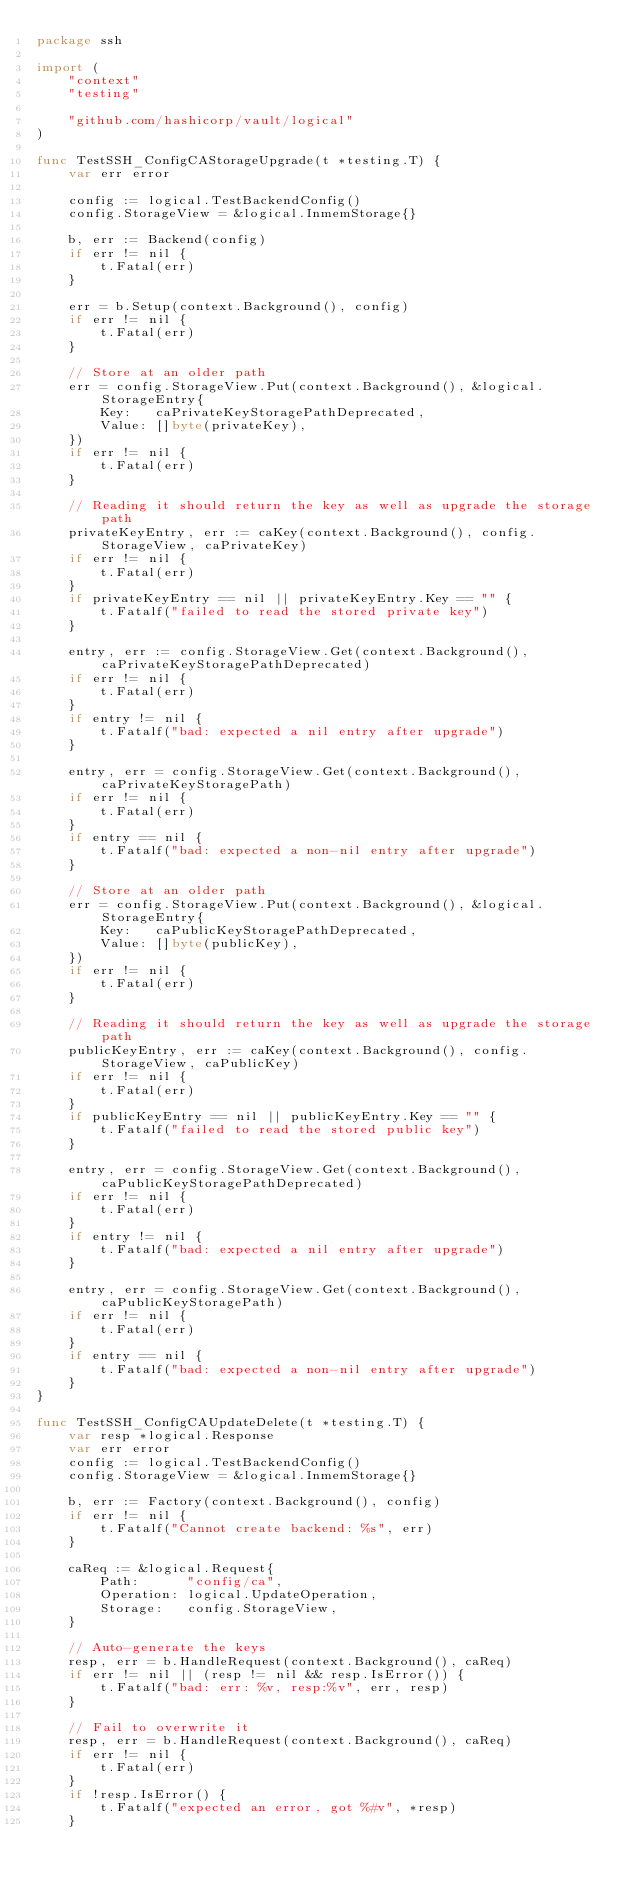Convert code to text. <code><loc_0><loc_0><loc_500><loc_500><_Go_>package ssh

import (
	"context"
	"testing"

	"github.com/hashicorp/vault/logical"
)

func TestSSH_ConfigCAStorageUpgrade(t *testing.T) {
	var err error

	config := logical.TestBackendConfig()
	config.StorageView = &logical.InmemStorage{}

	b, err := Backend(config)
	if err != nil {
		t.Fatal(err)
	}

	err = b.Setup(context.Background(), config)
	if err != nil {
		t.Fatal(err)
	}

	// Store at an older path
	err = config.StorageView.Put(context.Background(), &logical.StorageEntry{
		Key:   caPrivateKeyStoragePathDeprecated,
		Value: []byte(privateKey),
	})
	if err != nil {
		t.Fatal(err)
	}

	// Reading it should return the key as well as upgrade the storage path
	privateKeyEntry, err := caKey(context.Background(), config.StorageView, caPrivateKey)
	if err != nil {
		t.Fatal(err)
	}
	if privateKeyEntry == nil || privateKeyEntry.Key == "" {
		t.Fatalf("failed to read the stored private key")
	}

	entry, err := config.StorageView.Get(context.Background(), caPrivateKeyStoragePathDeprecated)
	if err != nil {
		t.Fatal(err)
	}
	if entry != nil {
		t.Fatalf("bad: expected a nil entry after upgrade")
	}

	entry, err = config.StorageView.Get(context.Background(), caPrivateKeyStoragePath)
	if err != nil {
		t.Fatal(err)
	}
	if entry == nil {
		t.Fatalf("bad: expected a non-nil entry after upgrade")
	}

	// Store at an older path
	err = config.StorageView.Put(context.Background(), &logical.StorageEntry{
		Key:   caPublicKeyStoragePathDeprecated,
		Value: []byte(publicKey),
	})
	if err != nil {
		t.Fatal(err)
	}

	// Reading it should return the key as well as upgrade the storage path
	publicKeyEntry, err := caKey(context.Background(), config.StorageView, caPublicKey)
	if err != nil {
		t.Fatal(err)
	}
	if publicKeyEntry == nil || publicKeyEntry.Key == "" {
		t.Fatalf("failed to read the stored public key")
	}

	entry, err = config.StorageView.Get(context.Background(), caPublicKeyStoragePathDeprecated)
	if err != nil {
		t.Fatal(err)
	}
	if entry != nil {
		t.Fatalf("bad: expected a nil entry after upgrade")
	}

	entry, err = config.StorageView.Get(context.Background(), caPublicKeyStoragePath)
	if err != nil {
		t.Fatal(err)
	}
	if entry == nil {
		t.Fatalf("bad: expected a non-nil entry after upgrade")
	}
}

func TestSSH_ConfigCAUpdateDelete(t *testing.T) {
	var resp *logical.Response
	var err error
	config := logical.TestBackendConfig()
	config.StorageView = &logical.InmemStorage{}

	b, err := Factory(context.Background(), config)
	if err != nil {
		t.Fatalf("Cannot create backend: %s", err)
	}

	caReq := &logical.Request{
		Path:      "config/ca",
		Operation: logical.UpdateOperation,
		Storage:   config.StorageView,
	}

	// Auto-generate the keys
	resp, err = b.HandleRequest(context.Background(), caReq)
	if err != nil || (resp != nil && resp.IsError()) {
		t.Fatalf("bad: err: %v, resp:%v", err, resp)
	}

	// Fail to overwrite it
	resp, err = b.HandleRequest(context.Background(), caReq)
	if err != nil {
		t.Fatal(err)
	}
	if !resp.IsError() {
		t.Fatalf("expected an error, got %#v", *resp)
	}
</code> 